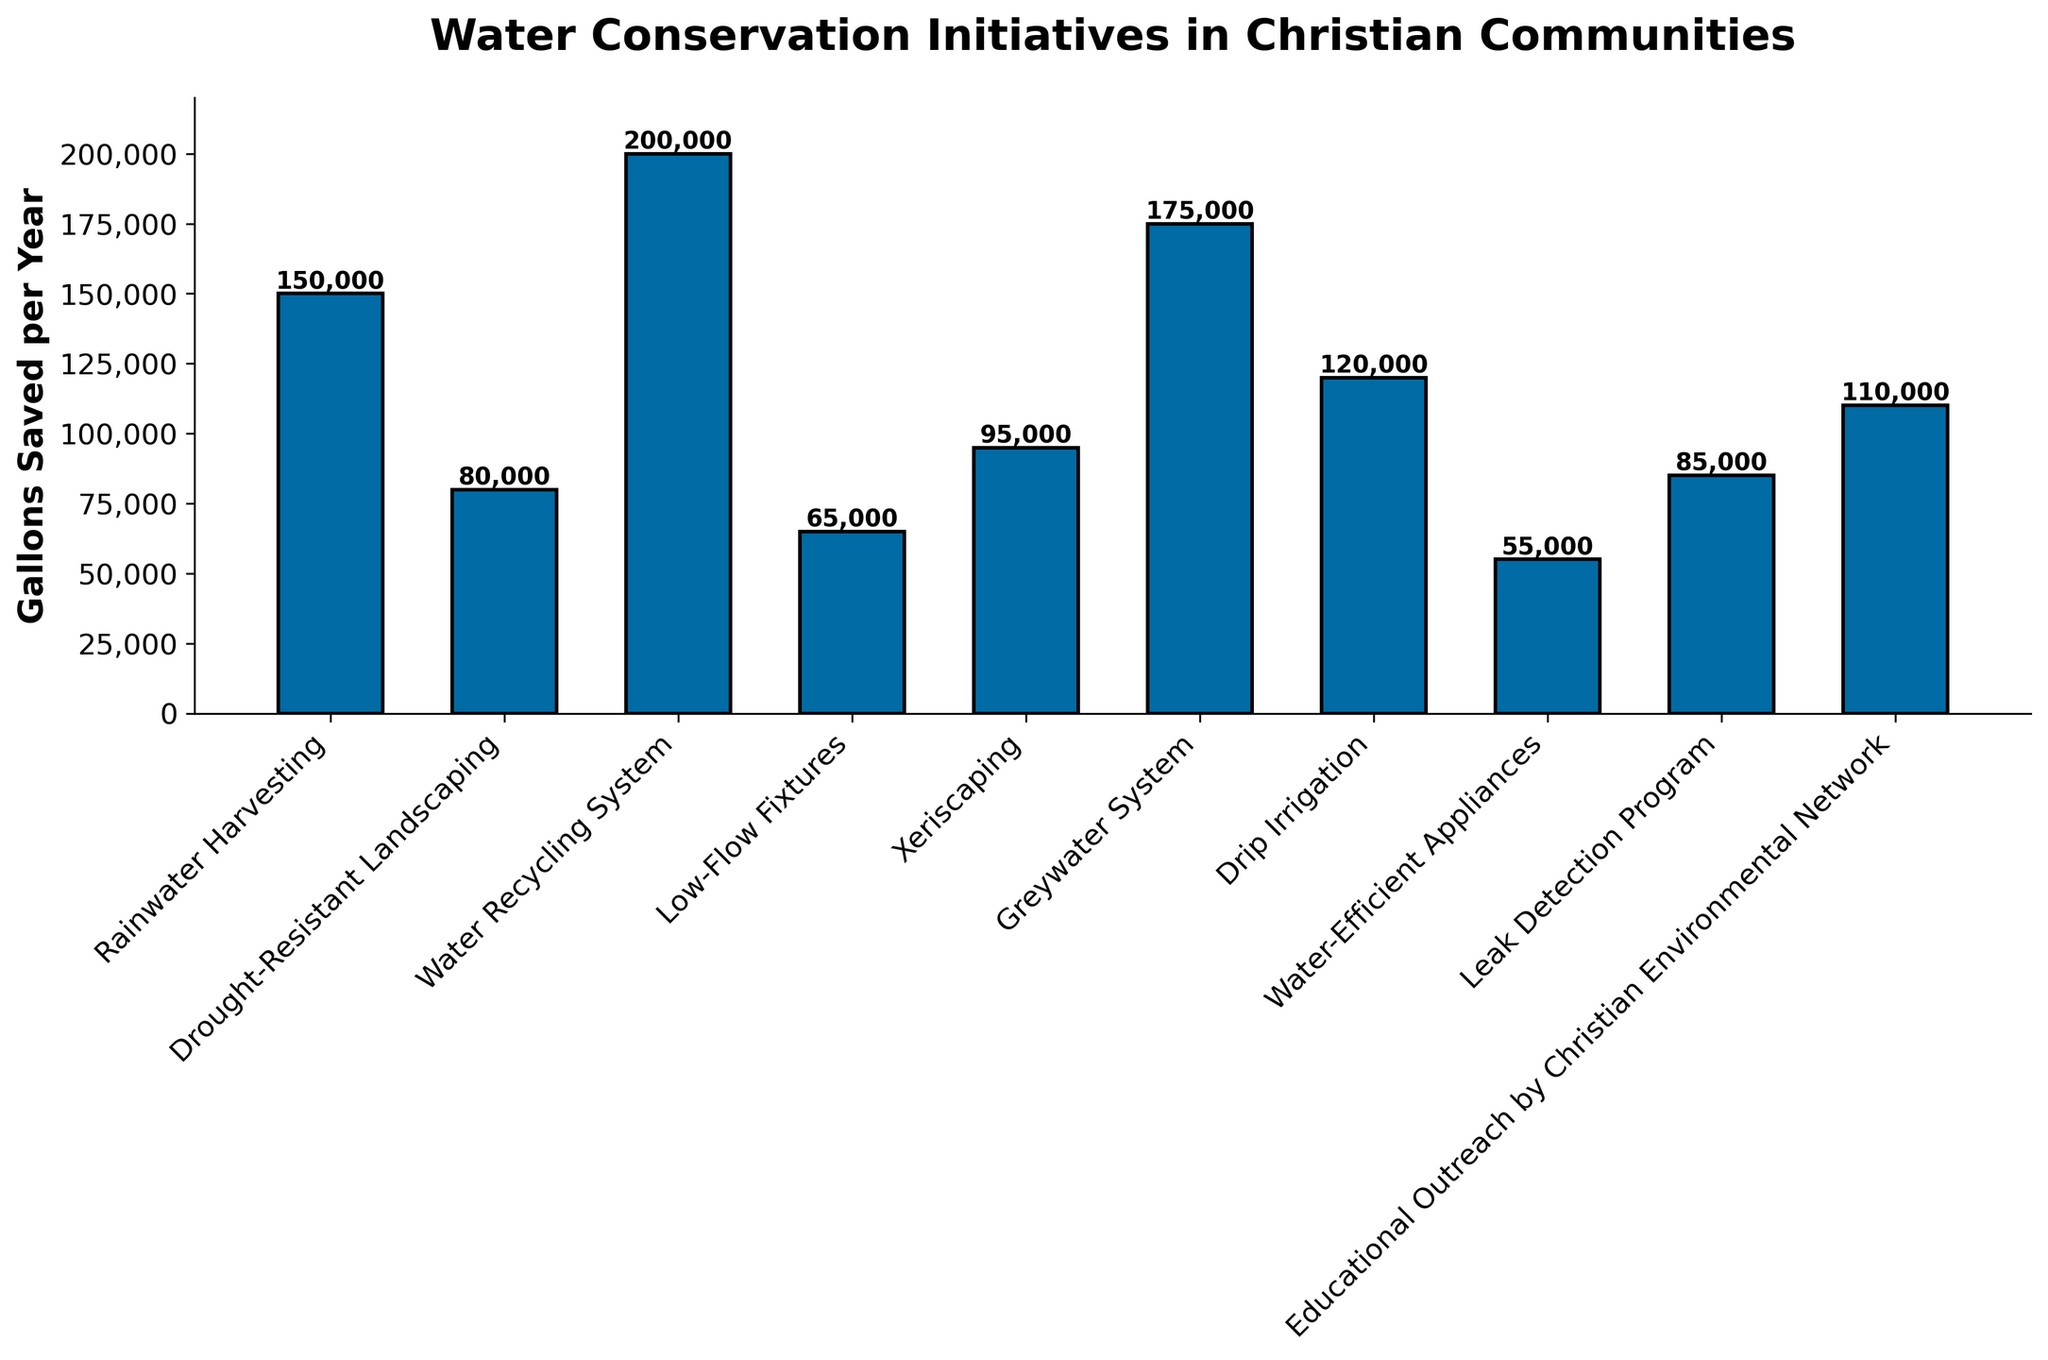What's the total number of gallons saved by the top three initiatives? First, we need to identify the top three initiatives. They are the Water Recycling System at Bethel Christian School (200,000 gallons), Greywater System at Calvary Chapel (175,000 gallons), and Rainwater Harvesting at First Baptist Church (150,000 gallons). Summing these values: 200,000 + 175,000 + 150,000 = 525,000.
Answer: 525,000 Which initiative saved the least amount of water? By looking at the height of the bars, we can see that Water-Efficient Appliances at St. Paul's Episcopal Church saved the least amount of water with 55,000 gallons.
Answer: Water-Efficient Appliances at St. Paul's Episcopal Church Is the total water saved by the Rainwater Harvesting at First Baptist Church and the Low-Flow Fixtures at Grace Community Church greater than the total saved by the Greywater System at Calvary Chapel? The water saved by Rainwater Harvesting at First Baptist Church is 150,000 gallons and the water saved by Low-Flow Fixtures at Grace Community Church is 65,000 gallons. Their sum is 150,000 + 65,000 = 215,000. The water saved by the Greywater System at Calvary Chapel is 175,000 gallons. So, 215,000 > 175,000.
Answer: Yes What is the difference in gallons saved between the most and least effective initiatives? The most effective initiative is the Water Recycling System at Bethel Christian School (200,000 gallons) and the least effective is Water-Efficient Appliances at St. Paul's Episcopal Church (55,000 gallons). The difference is 200,000 - 55,000 = 145,000 gallons.
Answer: 145,000 How does the water saved by Drip Irrigation at Living Word Bible Church compare to Educational Outreach by Christian Environmental Network? Drip Irrigation at Living Word Bible Church saved 120,000 gallons and Educational Outreach by Christian Environmental Network saved 110,000 gallons. So, Drip Irrigation saved 10,000 more gallons than Educational Outreach.
Answer: Drip Irrigation saved 10,000 more gallons What's the average amount of water saved per year by all initiatives? Sum all the gallons saved by each initiative: 150,000 + 80,000 + 200,000 + 65,000 + 95,000 + 175,000 + 120,000 + 55,000 + 85,000 + 110,000 = 1,135,000. There are 10 initiatives, so the average is 1,135,000 / 10 = 113,500 gallons.
Answer: 113,500 Which initiatives saved more than 100,000 gallons per year? By checking visually, the following initiatives saved more than 100,000 gallons per year: Rainwater Harvesting at First Baptist Church (150,000 gallons), Water Recycling System at Bethel Christian School (200,000 gallons), Greywater System at Calvary Chapel (175,000 gallons), Drip Irrigation at Living Word Bible Church (120,000 gallons), and Educational Outreach by Christian Environmental Network (110,000 gallons).
Answer: 5 